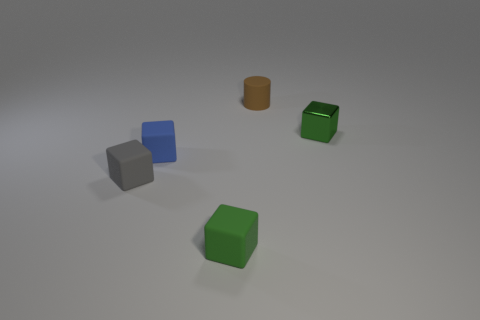There is a green thing that is on the left side of the brown cylinder; are there any blue matte blocks to the left of it?
Ensure brevity in your answer.  Yes. What number of small objects are green things or rubber cylinders?
Offer a terse response. 3. Are there any brown matte objects that have the same size as the rubber cylinder?
Your answer should be compact. No. What number of metal objects are either small cubes or tiny green blocks?
Your answer should be compact. 1. What shape is the other small object that is the same color as the tiny metal thing?
Provide a short and direct response. Cube. What number of small green objects are there?
Provide a short and direct response. 2. Do the small green thing that is to the left of the brown rubber cylinder and the thing that is behind the green metallic thing have the same material?
Make the answer very short. Yes. What size is the green block that is the same material as the gray cube?
Offer a very short reply. Small. There is a thing behind the green shiny thing; what shape is it?
Give a very brief answer. Cylinder. Do the block in front of the gray matte thing and the cube that is behind the tiny blue matte block have the same color?
Make the answer very short. Yes. 